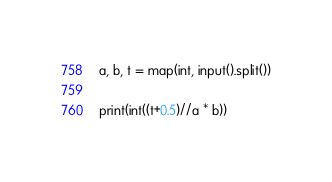Convert code to text. <code><loc_0><loc_0><loc_500><loc_500><_Python_>a, b, t = map(int, input().split())

print(int((t+0.5)//a * b))</code> 